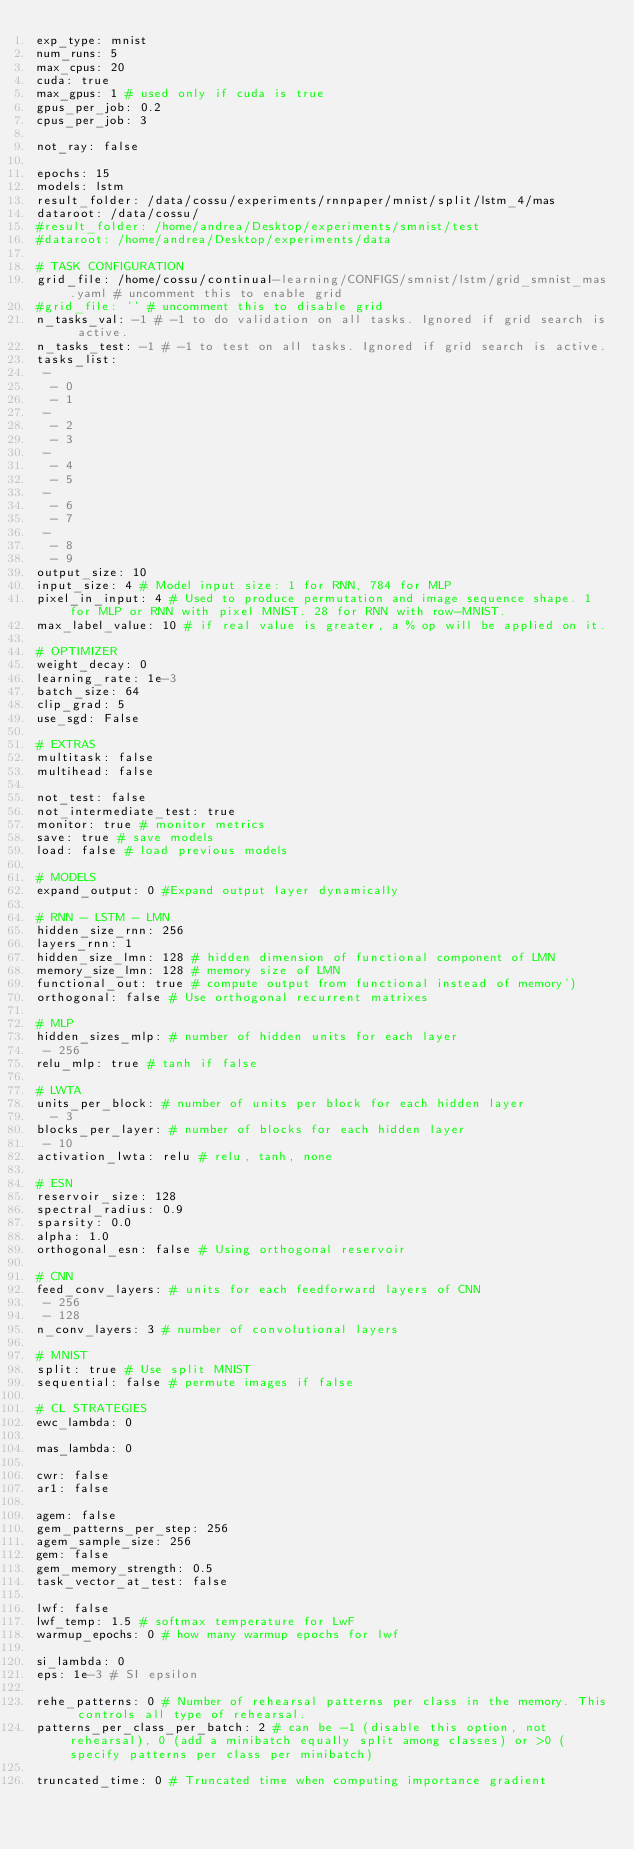<code> <loc_0><loc_0><loc_500><loc_500><_YAML_>exp_type: mnist
num_runs: 5
max_cpus: 20
cuda: true
max_gpus: 1 # used only if cuda is true
gpus_per_job: 0.2
cpus_per_job: 3

not_ray: false

epochs: 15
models: lstm
result_folder: /data/cossu/experiments/rnnpaper/mnist/split/lstm_4/mas
dataroot: /data/cossu/
#result_folder: /home/andrea/Desktop/experiments/smnist/test
#dataroot: /home/andrea/Desktop/experiments/data

# TASK CONFIGURATION
grid_file: /home/cossu/continual-learning/CONFIGS/smnist/lstm/grid_smnist_mas.yaml # uncomment this to enable grid
#grid_file: '' # uncomment this to disable grid
n_tasks_val: -1 # -1 to do validation on all tasks. Ignored if grid search is active.
n_tasks_test: -1 # -1 to test on all tasks. Ignored if grid search is active.
tasks_list: 
 - 
  - 0
  - 1
 - 
  - 2
  - 3
 - 
  - 4
  - 5
 - 
  - 6
  - 7
 - 
  - 8
  - 9
output_size: 10
input_size: 4 # Model input size: 1 for RNN, 784 for MLP
pixel_in_input: 4 # Used to produce permutation and image sequence shape. 1 for MLP or RNN with pixel MNIST. 28 for RNN with row-MNIST.
max_label_value: 10 # if real value is greater, a % op will be applied on it.

# OPTIMIZER
weight_decay: 0
learning_rate: 1e-3
batch_size: 64
clip_grad: 5
use_sgd: False

# EXTRAS
multitask: false
multihead: false

not_test: false
not_intermediate_test: true
monitor: true # monitor metrics
save: true # save models
load: false # load previous models

# MODELS
expand_output: 0 #Expand output layer dynamically

# RNN - LSTM - LMN
hidden_size_rnn: 256
layers_rnn: 1
hidden_size_lmn: 128 # hidden dimension of functional component of LMN
memory_size_lmn: 128 # memory size of LMN
functional_out: true # compute output from functional instead of memory')
orthogonal: false # Use orthogonal recurrent matrixes

# MLP
hidden_sizes_mlp: # number of hidden units for each layer
 - 256
relu_mlp: true # tanh if false

# LWTA
units_per_block: # number of units per block for each hidden layer
  - 3
blocks_per_layer: # number of blocks for each hidden layer
 - 10
activation_lwta: relu # relu, tanh, none

# ESN
reservoir_size: 128
spectral_radius: 0.9
sparsity: 0.0
alpha: 1.0
orthogonal_esn: false # Using orthogonal reservoir

# CNN
feed_conv_layers: # units for each feedforward layers of CNN
 - 256
 - 128
n_conv_layers: 3 # number of convolutional layers

# MNIST
split: true # Use split MNIST
sequential: false # permute images if false

# CL STRATEGIES
ewc_lambda: 0

mas_lambda: 0

cwr: false
ar1: false

agem: false
gem_patterns_per_step: 256
agem_sample_size: 256
gem: false
gem_memory_strength: 0.5
task_vector_at_test: false

lwf: false
lwf_temp: 1.5 # softmax temperature for LwF
warmup_epochs: 0 # how many warmup epochs for lwf

si_lambda: 0
eps: 1e-3 # SI epsilon

rehe_patterns: 0 # Number of rehearsal patterns per class in the memory. This controls all type of rehearsal.
patterns_per_class_per_batch: 2 # can be -1 (disable this option, not rehearsal), 0 (add a minibatch equally split among classes) or >0 (specify patterns per class per minibatch)

truncated_time: 0 # Truncated time when computing importance gradient
</code> 